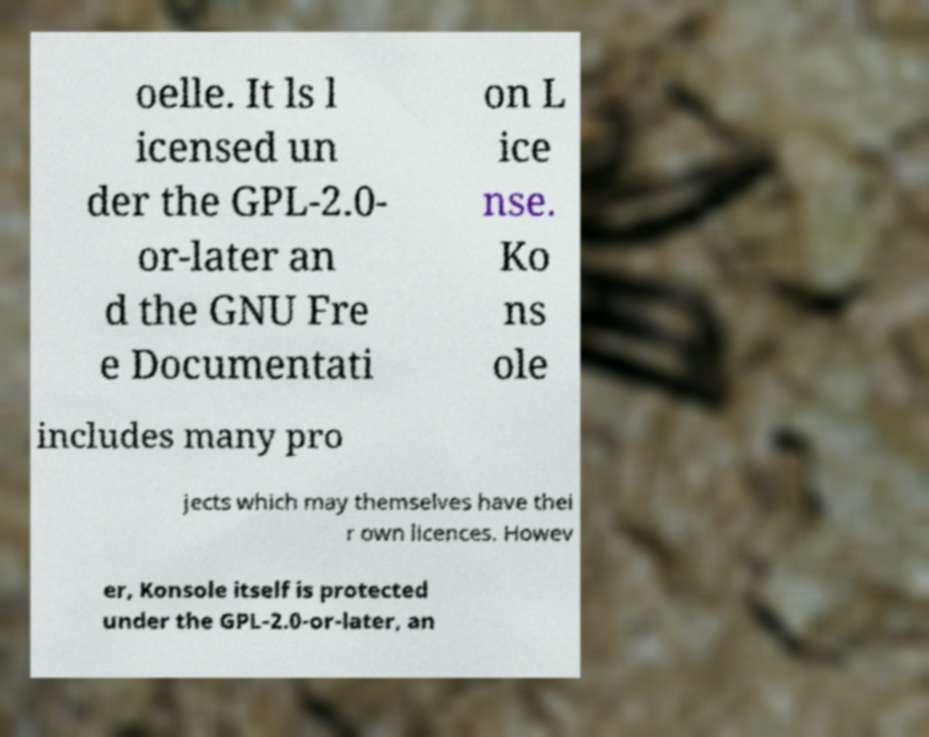Please read and relay the text visible in this image. What does it say? oelle. It ls l icensed un der the GPL-2.0- or-later an d the GNU Fre e Documentati on L ice nse. Ko ns ole includes many pro jects which may themselves have thei r own licences. Howev er, Konsole itself is protected under the GPL-2.0-or-later, an 